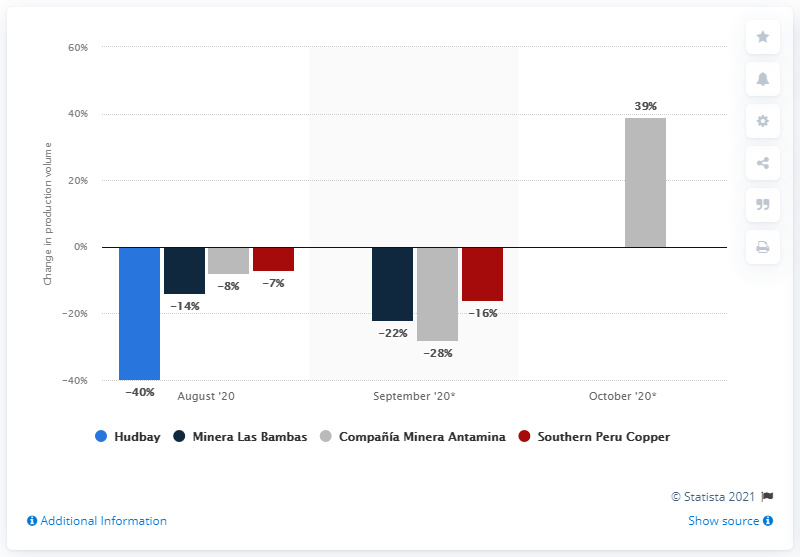Mention a couple of crucial points in this snapshot. Antamina's copper production increased by 39% year-on-year in October. 